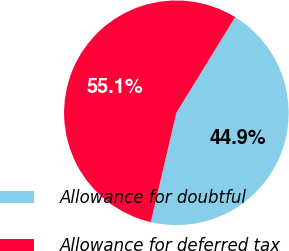<chart> <loc_0><loc_0><loc_500><loc_500><pie_chart><fcel>Allowance for doubtful<fcel>Allowance for deferred tax<nl><fcel>44.9%<fcel>55.1%<nl></chart> 